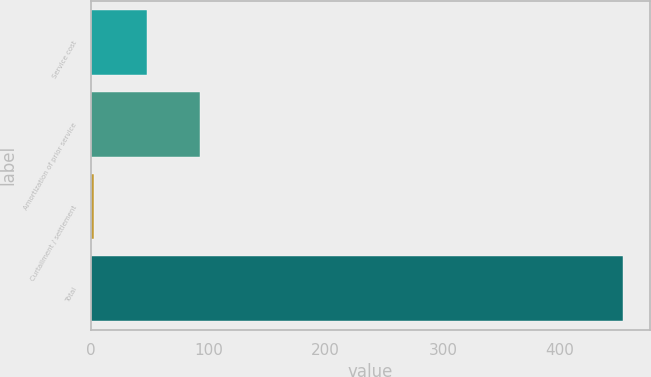Convert chart to OTSL. <chart><loc_0><loc_0><loc_500><loc_500><bar_chart><fcel>Service cost<fcel>Amortization of prior service<fcel>Curtailment / settlement<fcel>Total<nl><fcel>47.2<fcel>92.4<fcel>2<fcel>454<nl></chart> 